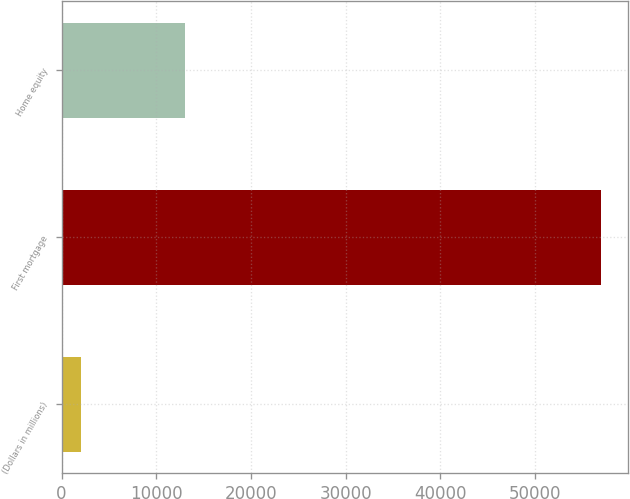Convert chart. <chart><loc_0><loc_0><loc_500><loc_500><bar_chart><fcel>(Dollars in millions)<fcel>First mortgage<fcel>Home equity<nl><fcel>2015<fcel>56930<fcel>13060<nl></chart> 